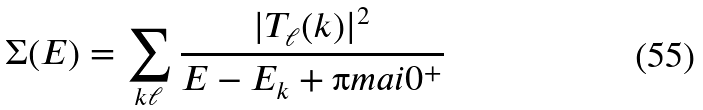<formula> <loc_0><loc_0><loc_500><loc_500>\Sigma ( E ) = \sum _ { k \ell } \frac { | T _ { \ell } ( k ) | ^ { 2 } } { E - E _ { k } + \i m a i 0 ^ { + } }</formula> 